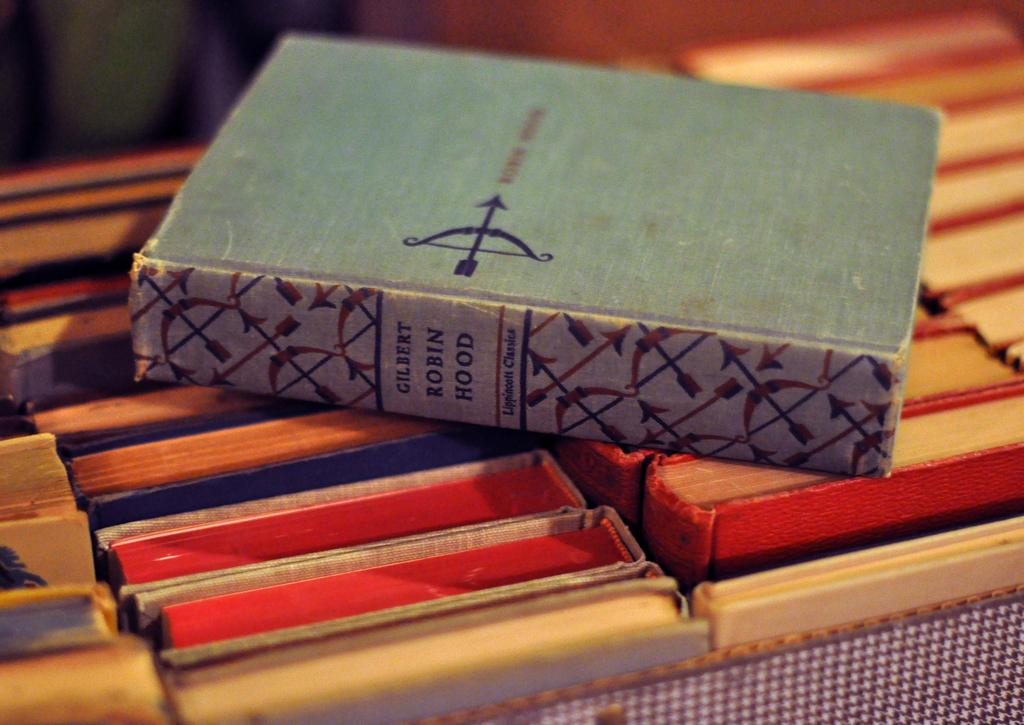<image>
Write a terse but informative summary of the picture. An old Robin Hood book is sitting on top of other books. 